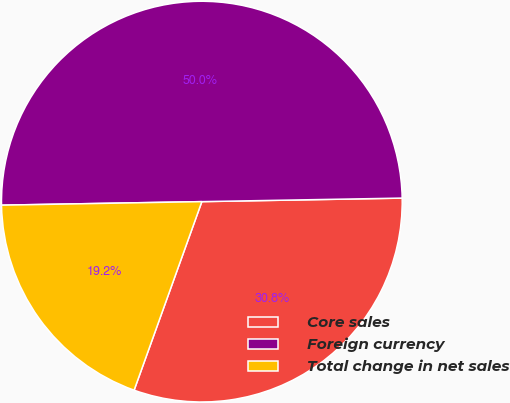Convert chart to OTSL. <chart><loc_0><loc_0><loc_500><loc_500><pie_chart><fcel>Core sales<fcel>Foreign currency<fcel>Total change in net sales<nl><fcel>30.77%<fcel>50.0%<fcel>19.23%<nl></chart> 